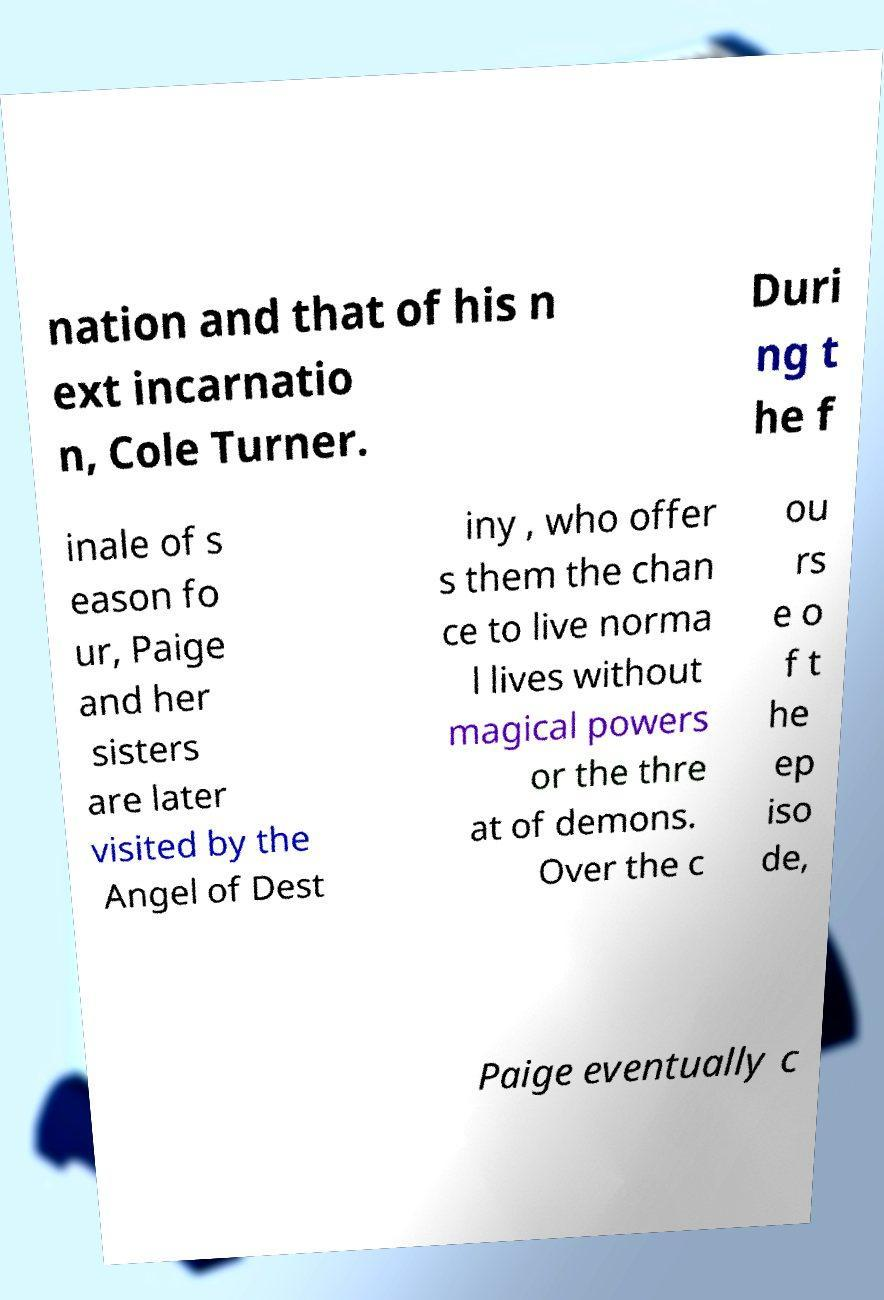Please read and relay the text visible in this image. What does it say? nation and that of his n ext incarnatio n, Cole Turner. Duri ng t he f inale of s eason fo ur, Paige and her sisters are later visited by the Angel of Dest iny , who offer s them the chan ce to live norma l lives without magical powers or the thre at of demons. Over the c ou rs e o f t he ep iso de, Paige eventually c 